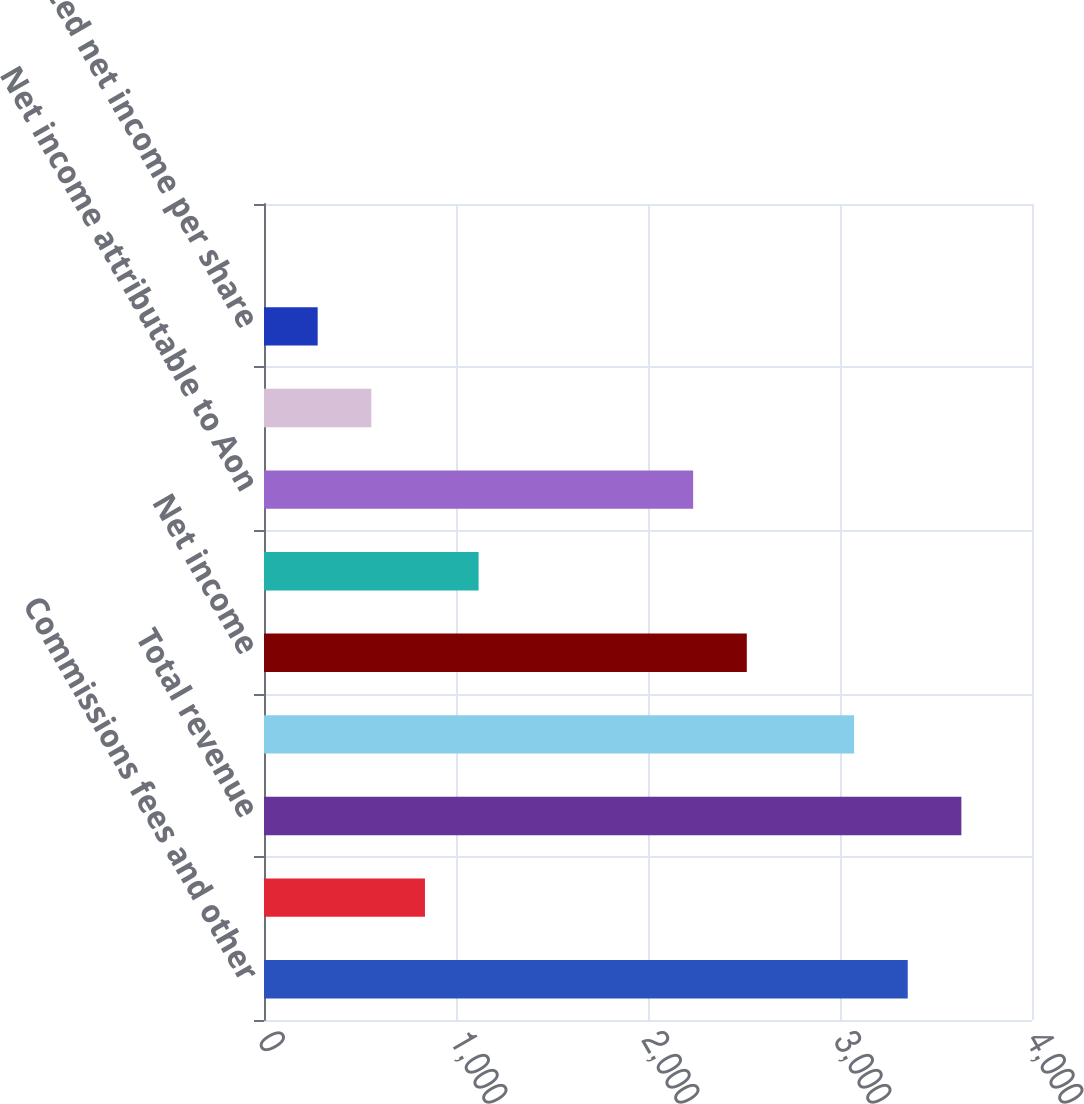Convert chart to OTSL. <chart><loc_0><loc_0><loc_500><loc_500><bar_chart><fcel>Commissions fees and other<fcel>Fiduciary investment income<fcel>Total revenue<fcel>Operating income<fcel>Net income<fcel>Less Net income attributable<fcel>Net income attributable to Aon<fcel>Basic net income per share<fcel>Diluted net income per share<fcel>Dividends paid per share<nl><fcel>3352.74<fcel>838.32<fcel>3632.12<fcel>3073.36<fcel>2514.6<fcel>1117.7<fcel>2235.22<fcel>558.94<fcel>279.56<fcel>0.18<nl></chart> 